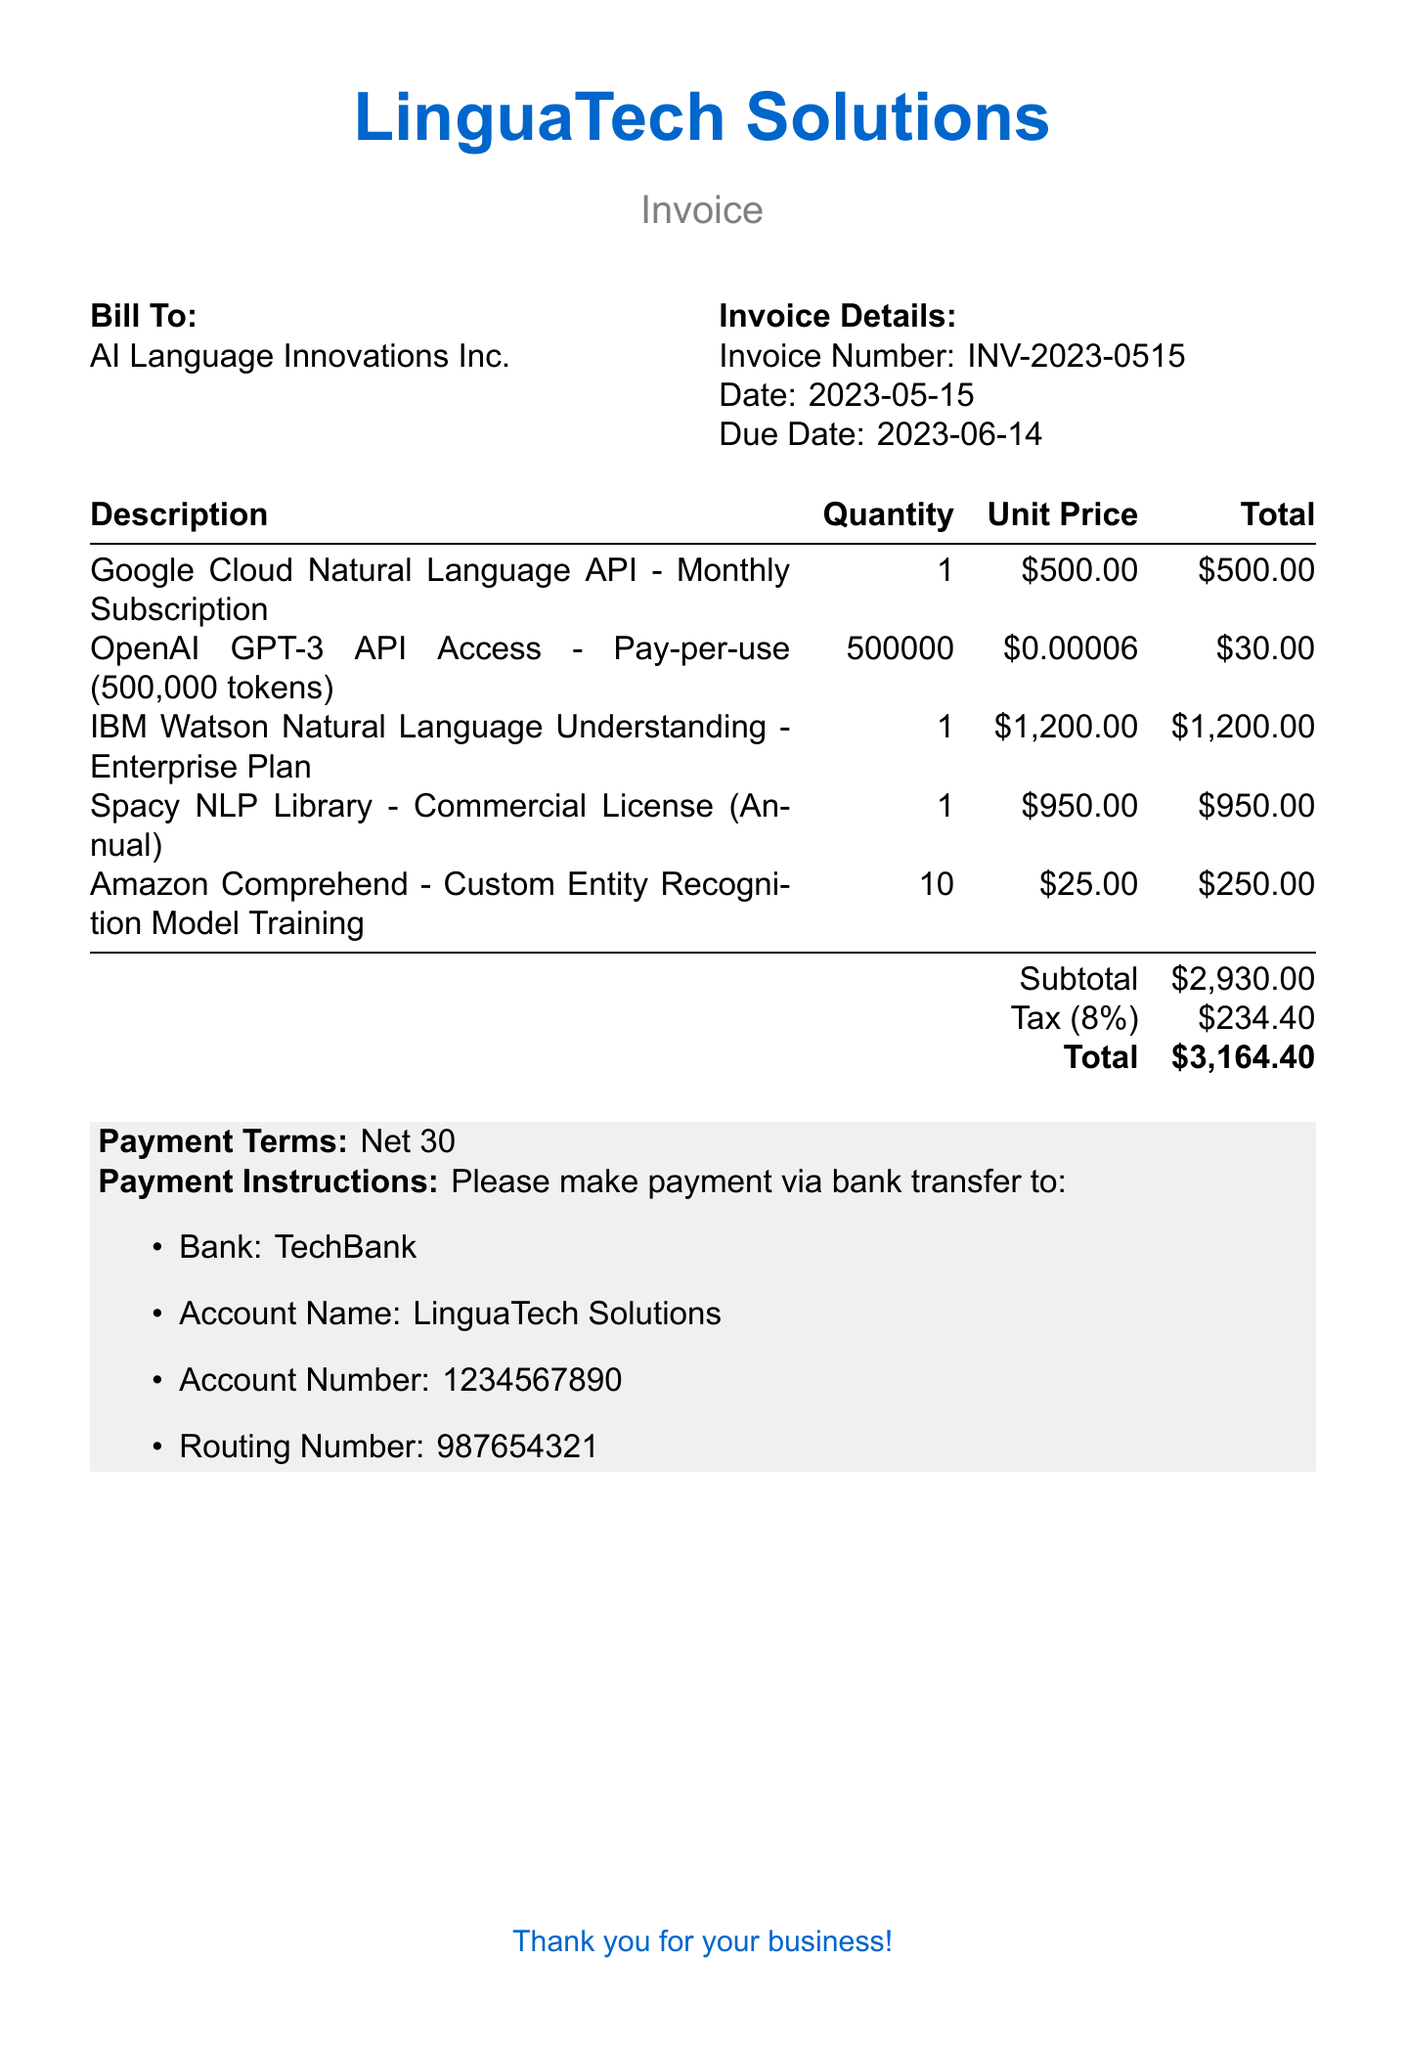What is the invoice number? The invoice number is specifically mentioned in the invoice details section.
Answer: INV-2023-0515 What is the due date? The due date is clearly stated in the invoice details.
Answer: 2023-06-14 What is the quantity of OpenAI GPT-3 API access tokens? The quantity for OpenAI GPT-3 API access is specified in the table under the description.
Answer: 500000 What is the subtotal amount before tax? The subtotal is calculated from all items listed before tax in the document.
Answer: $2,930.00 What is the tax percentage applied? The tax is explicitly mentioned as a percentage next to its amount.
Answer: 8% How much is the total amount due? The total amount is the final sum located at the bottom of the invoice table.
Answer: $3,164.40 Which payment method is requested? The document clearly outlines the payment instruction method as a bank transfer.
Answer: Bank transfer What is the payment term specified? The payment terms are stated directly under the payment instructions in the document.
Answer: Net 30 What is the name of the bank for the transfer? The bank's name is provided under the payment instructions section.
Answer: TechBank 